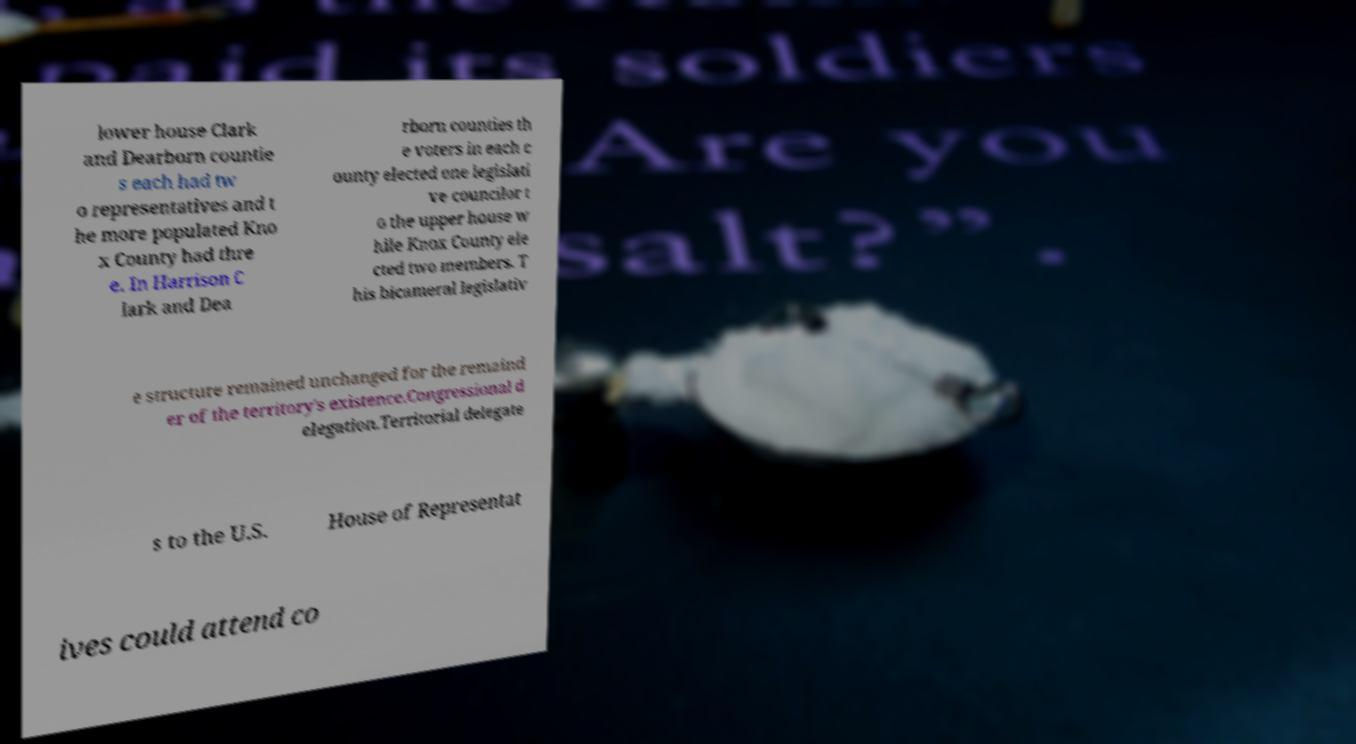There's text embedded in this image that I need extracted. Can you transcribe it verbatim? lower house Clark and Dearborn countie s each had tw o representatives and t he more populated Kno x County had thre e. In Harrison C lark and Dea rborn counties th e voters in each c ounty elected one legislati ve councilor t o the upper house w hile Knox County ele cted two members. T his bicameral legislativ e structure remained unchanged for the remaind er of the territory's existence.Congressional d elegation.Territorial delegate s to the U.S. House of Representat ives could attend co 